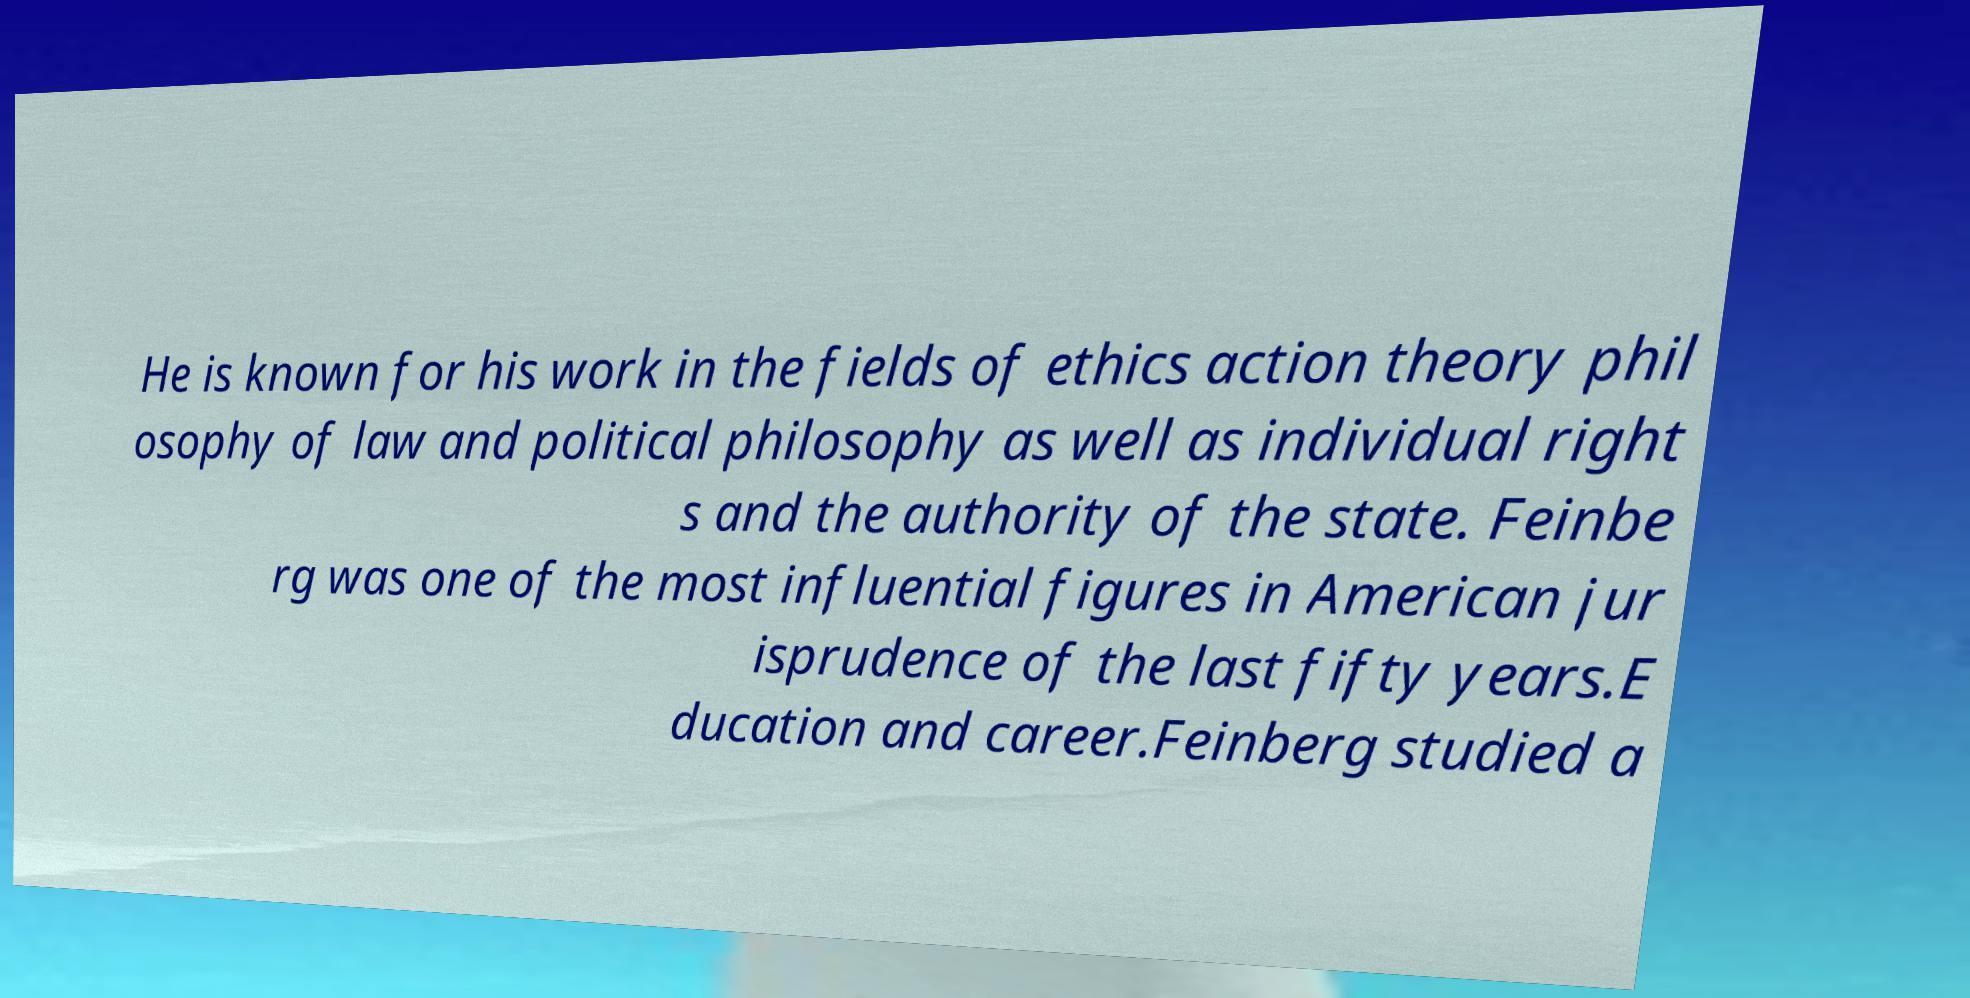For documentation purposes, I need the text within this image transcribed. Could you provide that? He is known for his work in the fields of ethics action theory phil osophy of law and political philosophy as well as individual right s and the authority of the state. Feinbe rg was one of the most influential figures in American jur isprudence of the last fifty years.E ducation and career.Feinberg studied a 